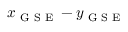Convert formula to latex. <formula><loc_0><loc_0><loc_500><loc_500>x _ { G S E } - y _ { G S E }</formula> 